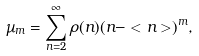<formula> <loc_0><loc_0><loc_500><loc_500>\mu _ { m } = \sum ^ { \infty } _ { n = 2 } \rho ( n ) ( n - < n > ) ^ { m } ,</formula> 